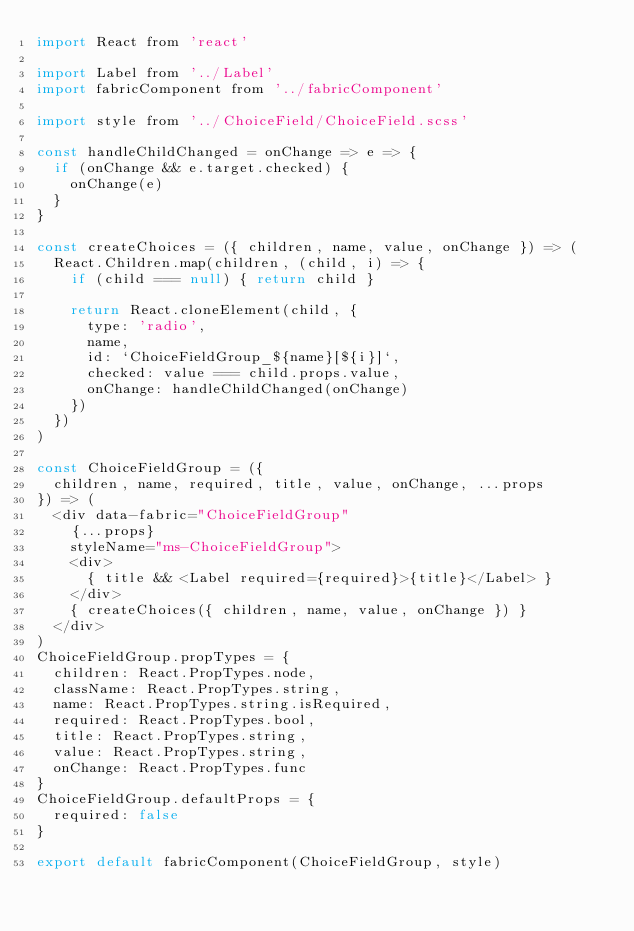<code> <loc_0><loc_0><loc_500><loc_500><_JavaScript_>import React from 'react'

import Label from '../Label'
import fabricComponent from '../fabricComponent'

import style from '../ChoiceField/ChoiceField.scss'

const handleChildChanged = onChange => e => {
  if (onChange && e.target.checked) {
    onChange(e)
  }
}

const createChoices = ({ children, name, value, onChange }) => (
  React.Children.map(children, (child, i) => {
    if (child === null) { return child }

    return React.cloneElement(child, {
      type: 'radio',
      name,
      id: `ChoiceFieldGroup_${name}[${i}]`,
      checked: value === child.props.value,
      onChange: handleChildChanged(onChange)
    })
  })
)

const ChoiceFieldGroup = ({
  children, name, required, title, value, onChange, ...props
}) => (
  <div data-fabric="ChoiceFieldGroup"
    {...props}
    styleName="ms-ChoiceFieldGroup">
    <div>
      { title && <Label required={required}>{title}</Label> }
    </div>
    { createChoices({ children, name, value, onChange }) }
  </div>
)
ChoiceFieldGroup.propTypes = {
  children: React.PropTypes.node,
  className: React.PropTypes.string,
  name: React.PropTypes.string.isRequired,
  required: React.PropTypes.bool,
  title: React.PropTypes.string,
  value: React.PropTypes.string,
  onChange: React.PropTypes.func
}
ChoiceFieldGroup.defaultProps = {
  required: false
}

export default fabricComponent(ChoiceFieldGroup, style)
</code> 